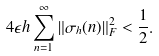<formula> <loc_0><loc_0><loc_500><loc_500>4 \epsilon h \sum _ { n = 1 } ^ { \infty } \| \sigma _ { h } ( n ) \| ^ { 2 } _ { F } < \frac { 1 } { 2 } .</formula> 